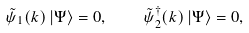<formula> <loc_0><loc_0><loc_500><loc_500>\tilde { \psi } _ { 1 } ( k ) \left | \Psi \right \rangle = 0 , \quad \tilde { \psi } _ { 2 } ^ { \dagger } ( k ) \left | \Psi \right \rangle = 0 ,</formula> 